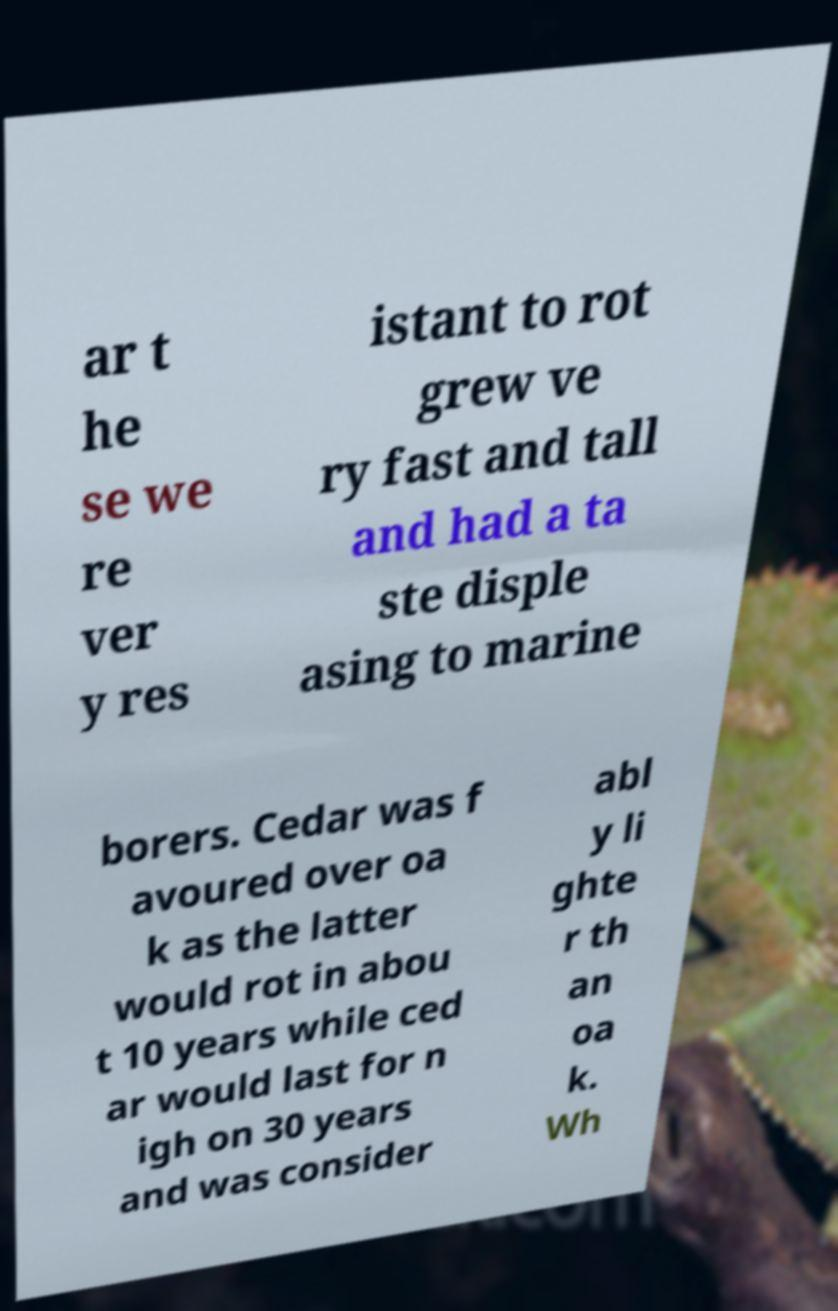Please read and relay the text visible in this image. What does it say? ar t he se we re ver y res istant to rot grew ve ry fast and tall and had a ta ste disple asing to marine borers. Cedar was f avoured over oa k as the latter would rot in abou t 10 years while ced ar would last for n igh on 30 years and was consider abl y li ghte r th an oa k. Wh 